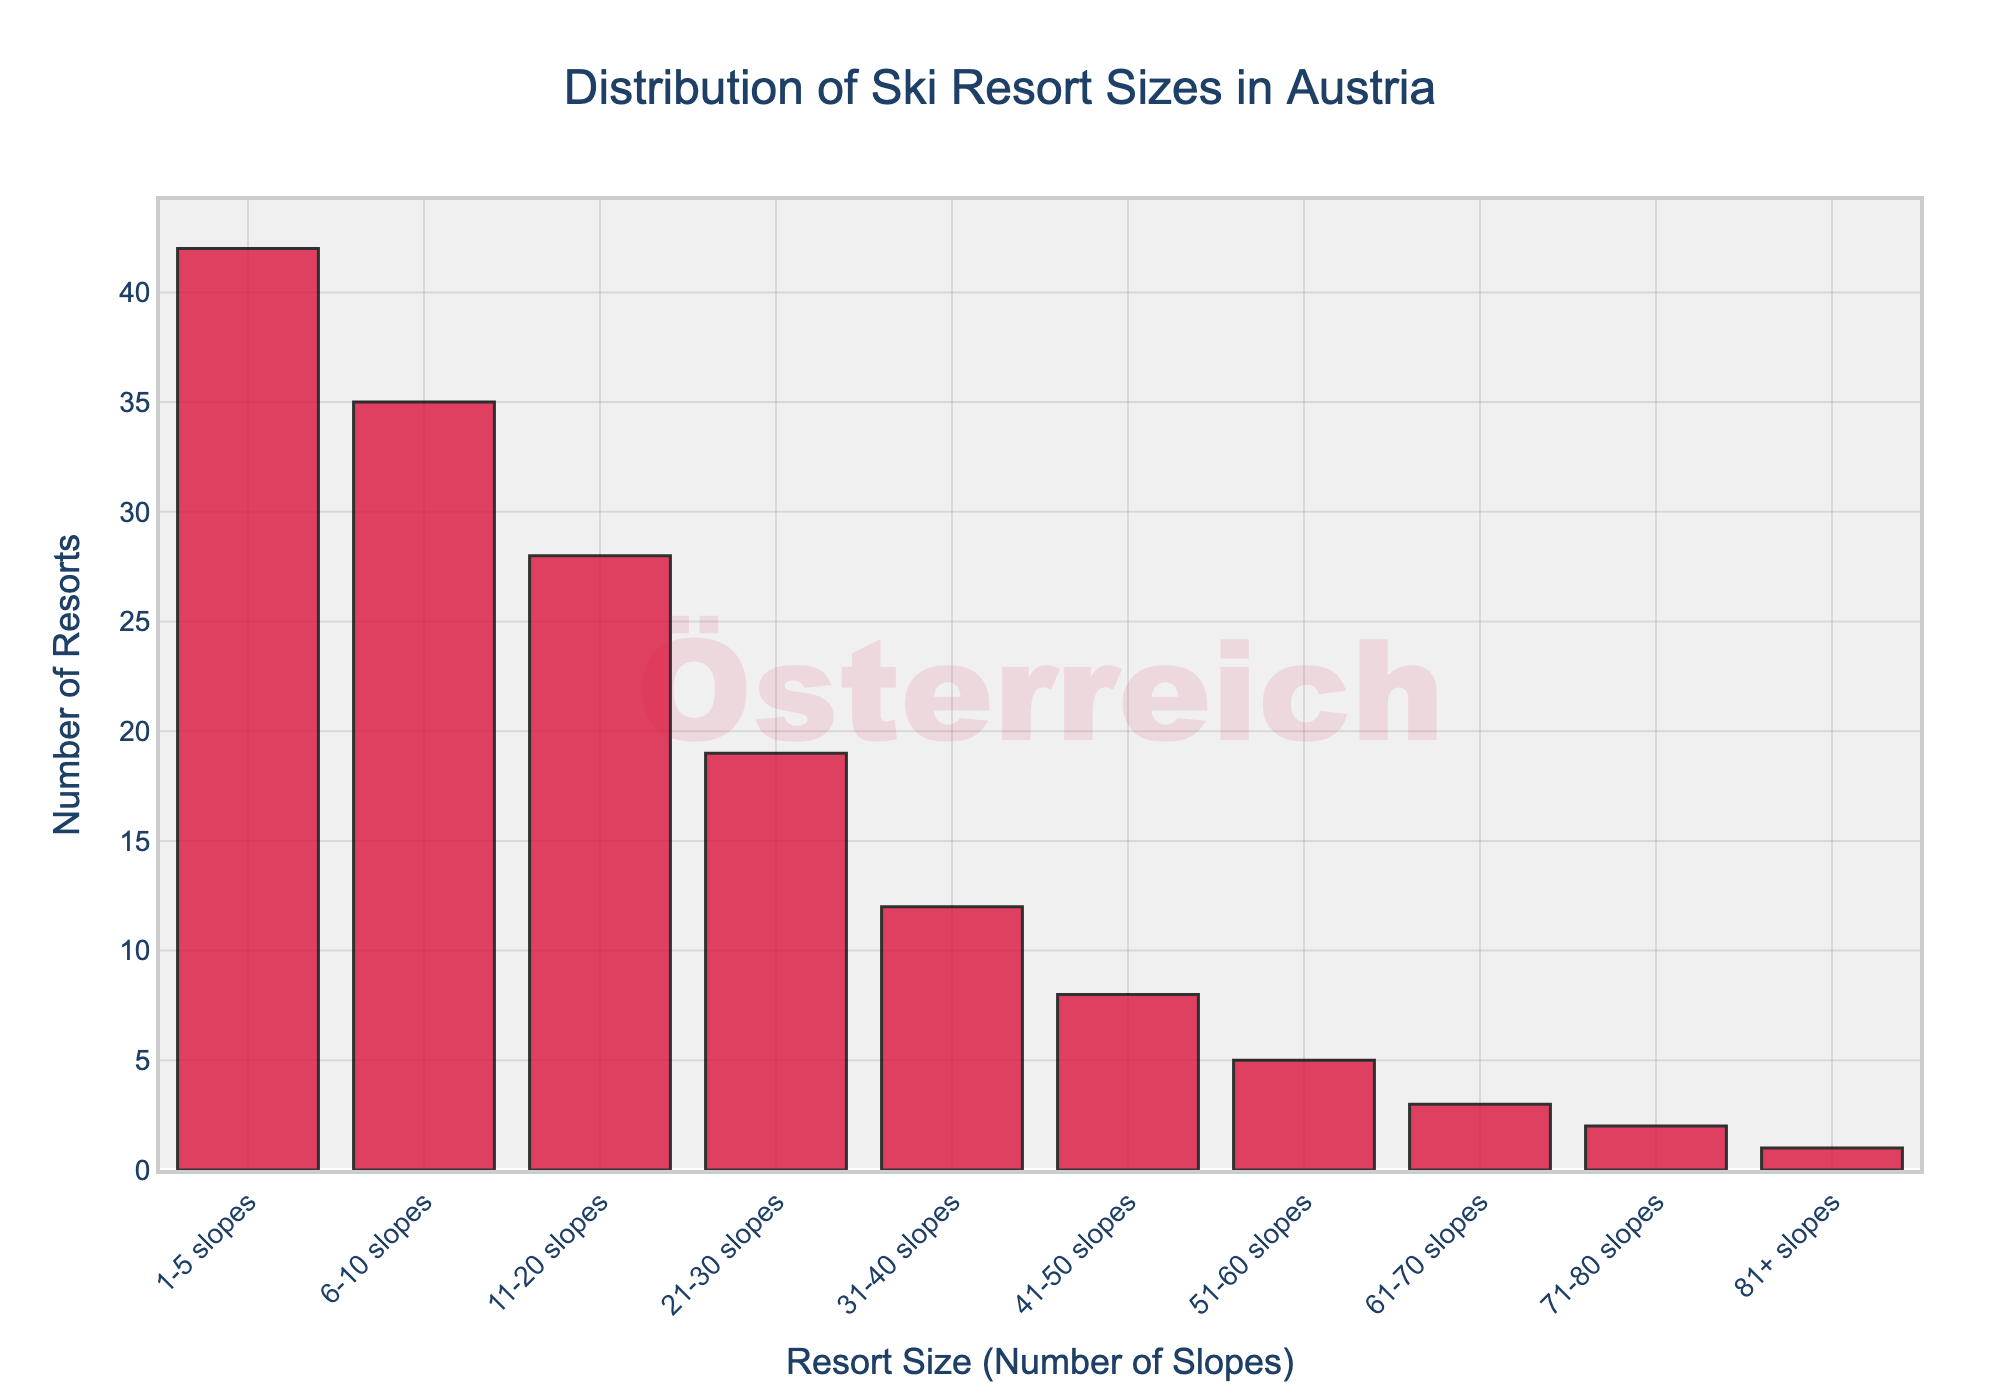What is the total number of ski resorts with 1-10 slopes? To find the total number of resorts with 1-10 slopes, add the number of resorts in the 1-5 slopes category and the 6-10 slopes category. That is 42 (1-5 slopes) + 35 (6-10 slopes) = 77.
Answer: 77 Which resort size category has the highest number of resorts? By observing the heights of the bars, the highest bar corresponds to the '1-5 slopes' category.
Answer: 1-5 slopes How many more resorts are there in the '1-5 slopes' category compared to the '81+ slopes' category? There are 42 resorts in the '1-5 slopes' category and 1 resort in the '81+ slopes' category. The difference is 42 - 1 = 41.
Answer: 41 In how many resort size categories do fewer than 10 resorts exist? By counting the categories where the number of resorts is less than 10, we find that '41-50 slopes' (8), '51-60 slopes' (5), '61-70 slopes' (3), '71-80 slopes' (2), and '81+ slopes' (1) all have fewer than 10 resorts. This makes 5 categories.
Answer: 5 What is the most predominant color of the bars in the chart? By observing the visual attributes of the bars, they are all in crimson red color.
Answer: Crimson red If you average the number of resorts for categories having 21-80 slopes, what is the result? Categories 21-30, 31-40, 41-50, 51-60, 61-70, and 71-80 slopes respectively have 19, 12, 8, 5, 3, and 2 resorts. Their sum is 19 + 12 + 8 + 5 + 3 + 2 = 49. There are 6 categories. Hence, the average is 49 / 6 = 8.17.
Answer: 8.17 Are there more resorts in the 11-20 slopes category or the 31-40 slopes category? The '11-20 slopes' category has 28 resorts, whereas the '31-40 slopes' category has 12 resorts. Therefore, there are more resorts in the '11-20 slopes' category.
Answer: 11-20 slopes Which category is closest to the average number of resorts across all categories? First, find the total number of resorts across all categories (42 + 35 + 28 + 19 + 12 + 8 + 5 + 3 + 2 + 1 = 155). There are 10 categories, so the average is 155 / 10 = 15.5. The category with 19 resorts (21-30 slopes) is the closest to this average.
Answer: 21-30 slopes What is the combined number of resorts in the '51-60 slopes' and '61-70 slopes' categories? Adding the number of resorts in the '51-60 slopes' (5 resorts) and '61-70 slopes' (3 resorts) categories gives us 5 + 3 = 8 resorts.
Answer: 8 